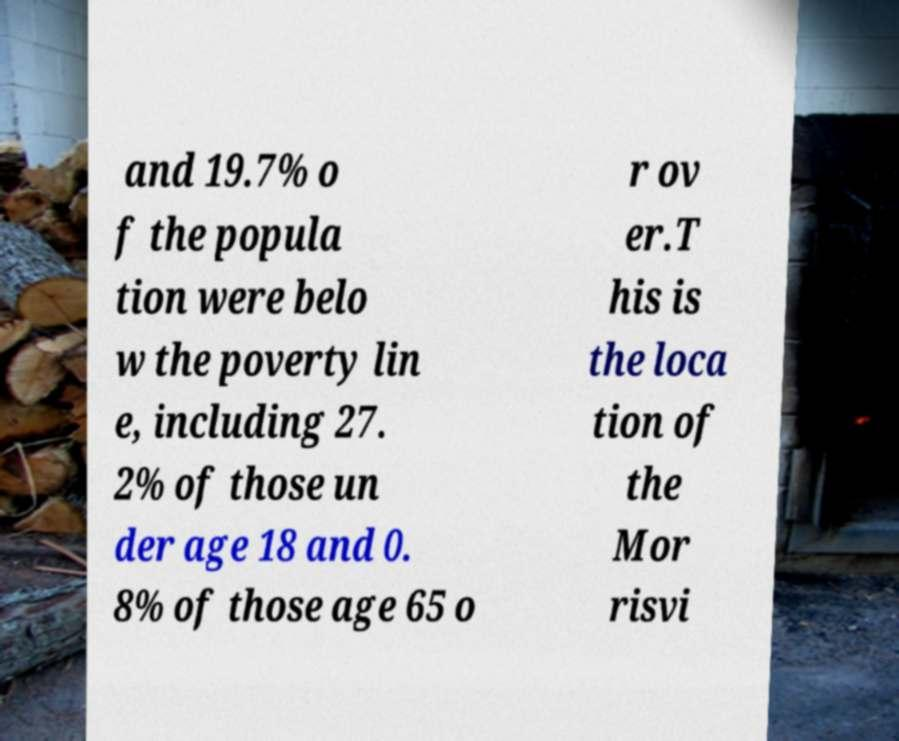I need the written content from this picture converted into text. Can you do that? and 19.7% o f the popula tion were belo w the poverty lin e, including 27. 2% of those un der age 18 and 0. 8% of those age 65 o r ov er.T his is the loca tion of the Mor risvi 